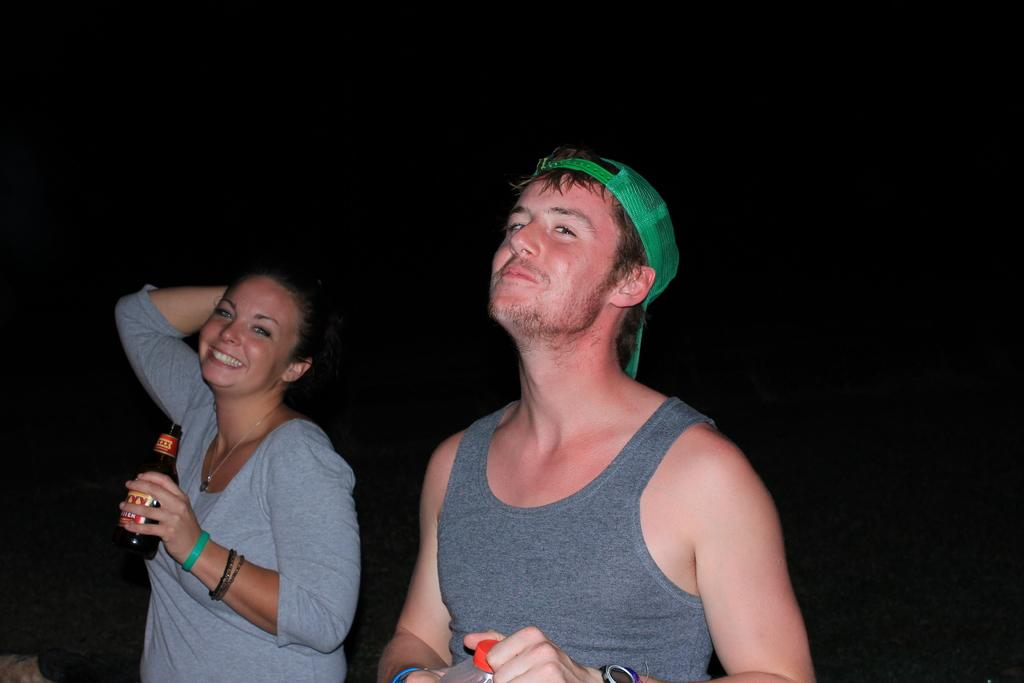How many people are in the image? There are two persons in the image. What are the two persons holding? The two persons are holding bottles. Can you describe the background of the image? The background of the image is dark. What type of machine is being used to crush the eggnog in the image? There is no machine or eggnog present in the image. 